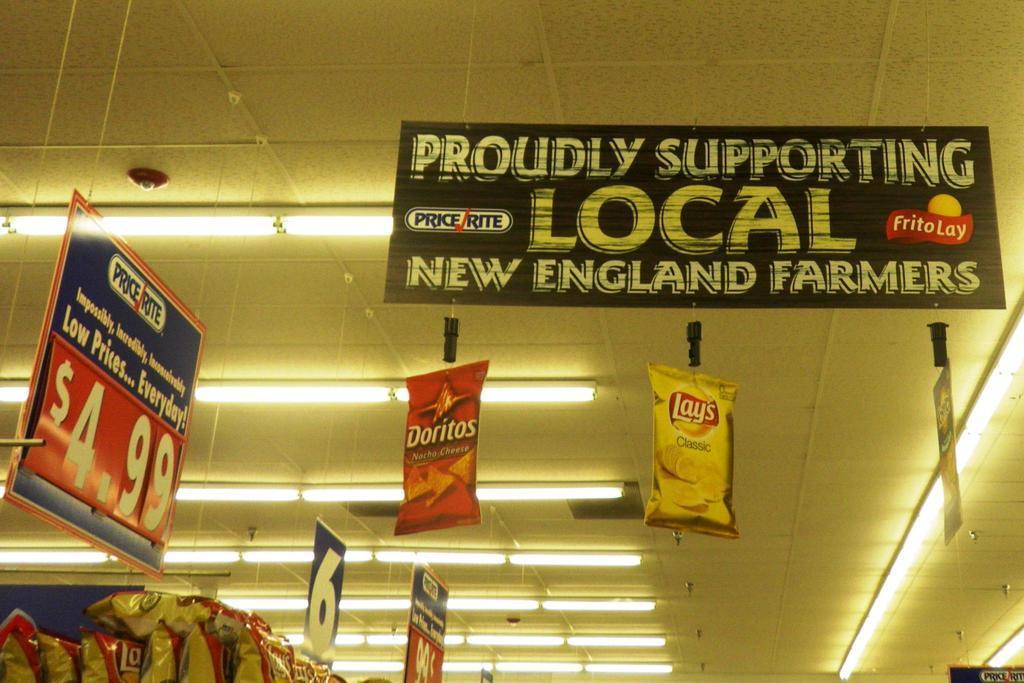Can you describe this image briefly? In this image I can see many boards and the lights at the top. To the left I can see many food packets. 